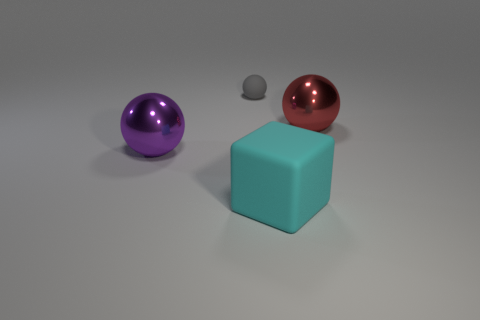Add 2 small balls. How many objects exist? 6 Subtract all blocks. How many objects are left? 3 Add 1 large red spheres. How many large red spheres are left? 2 Add 4 blue metallic cubes. How many blue metallic cubes exist? 4 Subtract 0 red blocks. How many objects are left? 4 Subtract all large shiny objects. Subtract all shiny spheres. How many objects are left? 0 